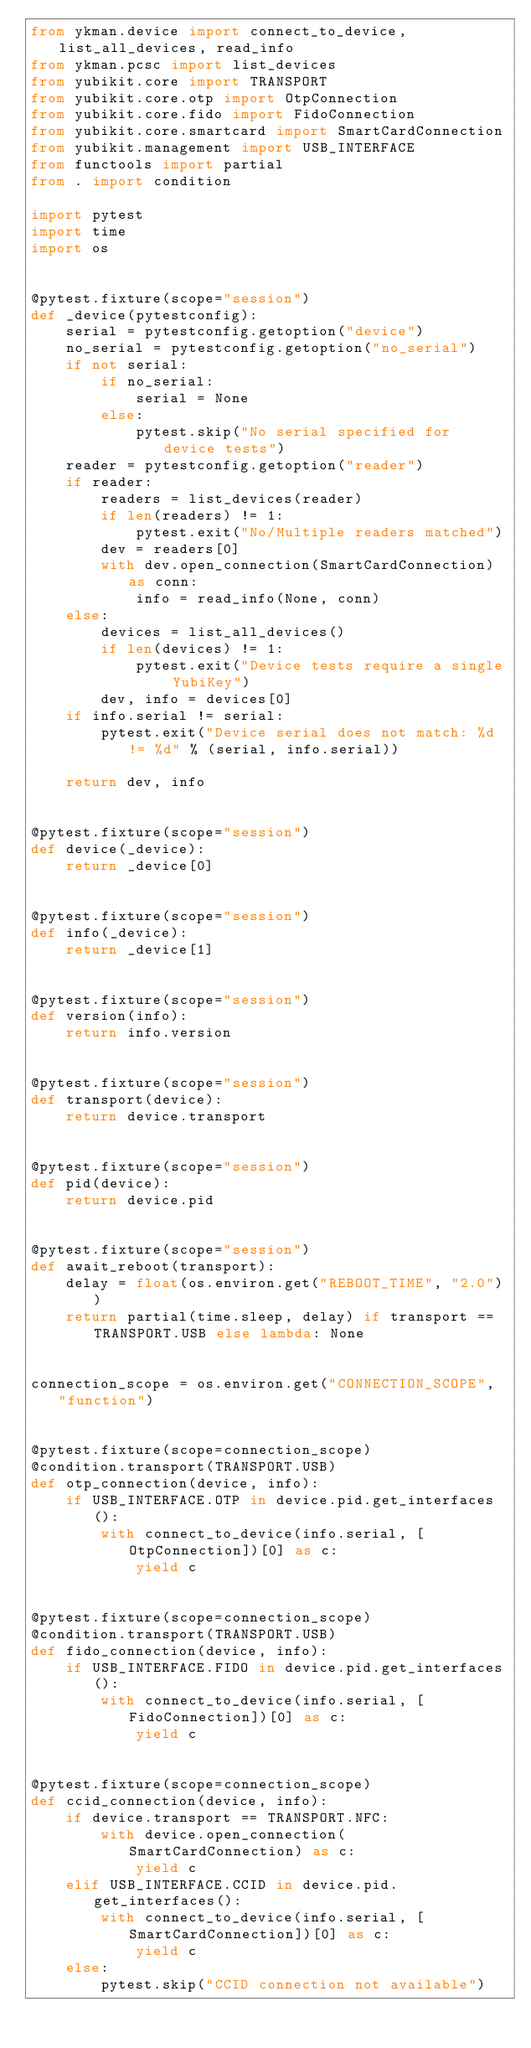<code> <loc_0><loc_0><loc_500><loc_500><_Python_>from ykman.device import connect_to_device, list_all_devices, read_info
from ykman.pcsc import list_devices
from yubikit.core import TRANSPORT
from yubikit.core.otp import OtpConnection
from yubikit.core.fido import FidoConnection
from yubikit.core.smartcard import SmartCardConnection
from yubikit.management import USB_INTERFACE
from functools import partial
from . import condition

import pytest
import time
import os


@pytest.fixture(scope="session")
def _device(pytestconfig):
    serial = pytestconfig.getoption("device")
    no_serial = pytestconfig.getoption("no_serial")
    if not serial:
        if no_serial:
            serial = None
        else:
            pytest.skip("No serial specified for device tests")
    reader = pytestconfig.getoption("reader")
    if reader:
        readers = list_devices(reader)
        if len(readers) != 1:
            pytest.exit("No/Multiple readers matched")
        dev = readers[0]
        with dev.open_connection(SmartCardConnection) as conn:
            info = read_info(None, conn)
    else:
        devices = list_all_devices()
        if len(devices) != 1:
            pytest.exit("Device tests require a single YubiKey")
        dev, info = devices[0]
    if info.serial != serial:
        pytest.exit("Device serial does not match: %d != %d" % (serial, info.serial))

    return dev, info


@pytest.fixture(scope="session")
def device(_device):
    return _device[0]


@pytest.fixture(scope="session")
def info(_device):
    return _device[1]


@pytest.fixture(scope="session")
def version(info):
    return info.version


@pytest.fixture(scope="session")
def transport(device):
    return device.transport


@pytest.fixture(scope="session")
def pid(device):
    return device.pid


@pytest.fixture(scope="session")
def await_reboot(transport):
    delay = float(os.environ.get("REBOOT_TIME", "2.0"))
    return partial(time.sleep, delay) if transport == TRANSPORT.USB else lambda: None


connection_scope = os.environ.get("CONNECTION_SCOPE", "function")


@pytest.fixture(scope=connection_scope)
@condition.transport(TRANSPORT.USB)
def otp_connection(device, info):
    if USB_INTERFACE.OTP in device.pid.get_interfaces():
        with connect_to_device(info.serial, [OtpConnection])[0] as c:
            yield c


@pytest.fixture(scope=connection_scope)
@condition.transport(TRANSPORT.USB)
def fido_connection(device, info):
    if USB_INTERFACE.FIDO in device.pid.get_interfaces():
        with connect_to_device(info.serial, [FidoConnection])[0] as c:
            yield c


@pytest.fixture(scope=connection_scope)
def ccid_connection(device, info):
    if device.transport == TRANSPORT.NFC:
        with device.open_connection(SmartCardConnection) as c:
            yield c
    elif USB_INTERFACE.CCID in device.pid.get_interfaces():
        with connect_to_device(info.serial, [SmartCardConnection])[0] as c:
            yield c
    else:
        pytest.skip("CCID connection not available")
</code> 